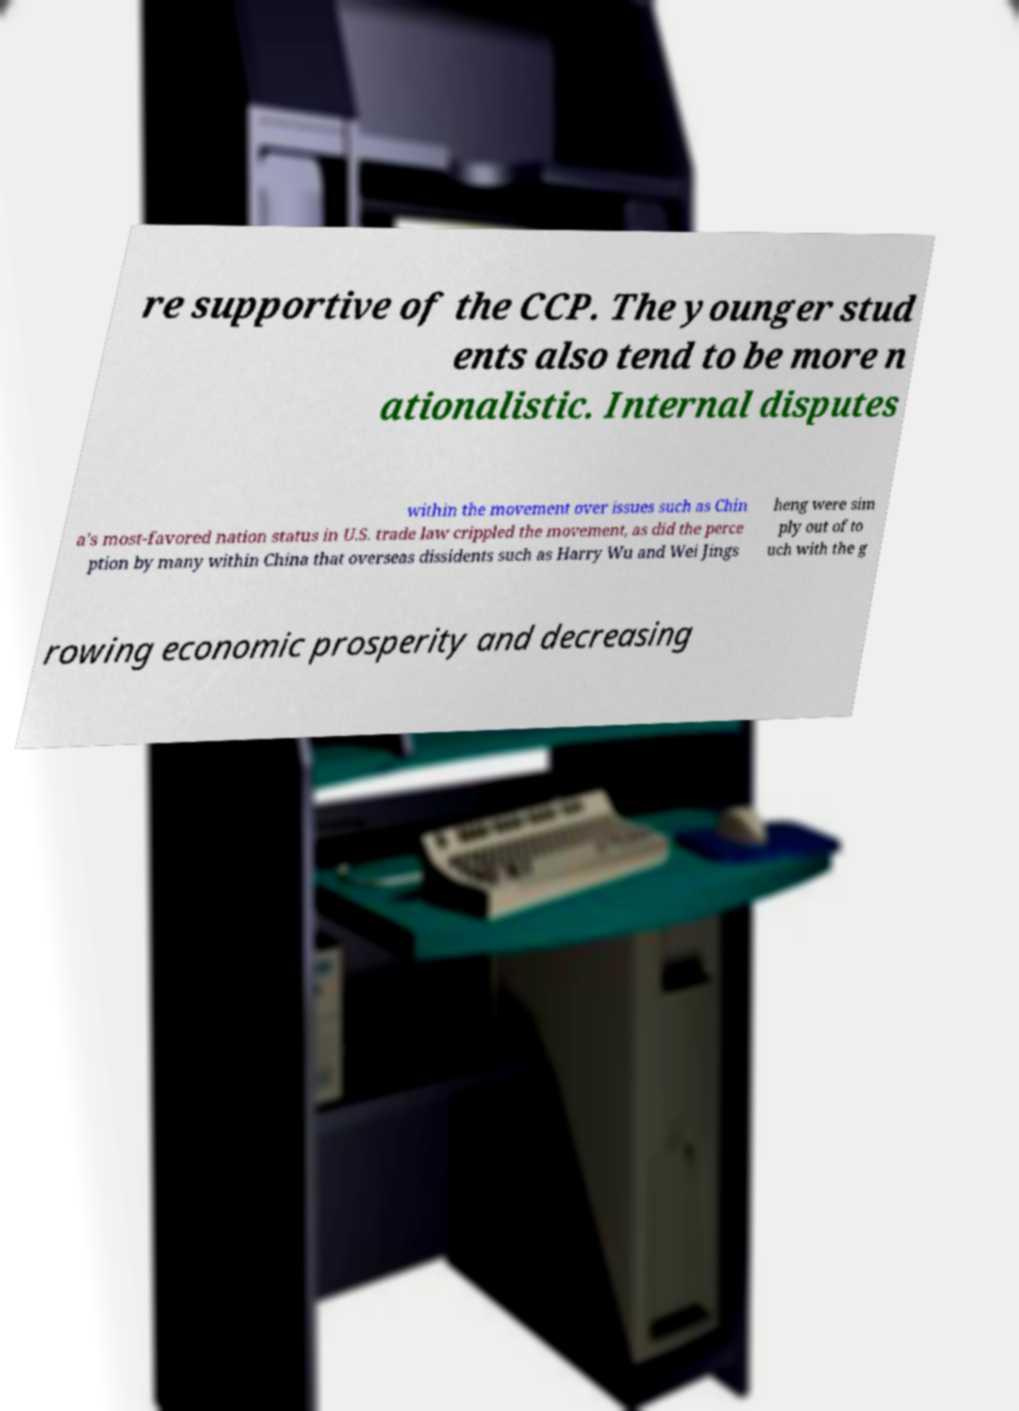Can you read and provide the text displayed in the image?This photo seems to have some interesting text. Can you extract and type it out for me? re supportive of the CCP. The younger stud ents also tend to be more n ationalistic. Internal disputes within the movement over issues such as Chin a's most-favored nation status in U.S. trade law crippled the movement, as did the perce ption by many within China that overseas dissidents such as Harry Wu and Wei Jings heng were sim ply out of to uch with the g rowing economic prosperity and decreasing 